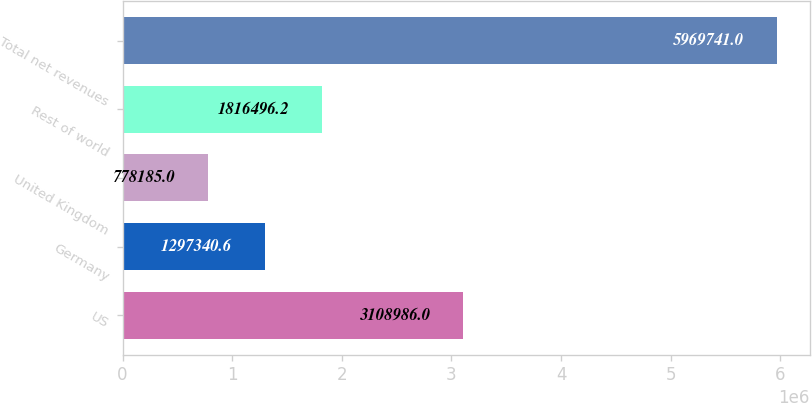<chart> <loc_0><loc_0><loc_500><loc_500><bar_chart><fcel>US<fcel>Germany<fcel>United Kingdom<fcel>Rest of world<fcel>Total net revenues<nl><fcel>3.10899e+06<fcel>1.29734e+06<fcel>778185<fcel>1.8165e+06<fcel>5.96974e+06<nl></chart> 